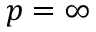Convert formula to latex. <formula><loc_0><loc_0><loc_500><loc_500>p = \infty</formula> 